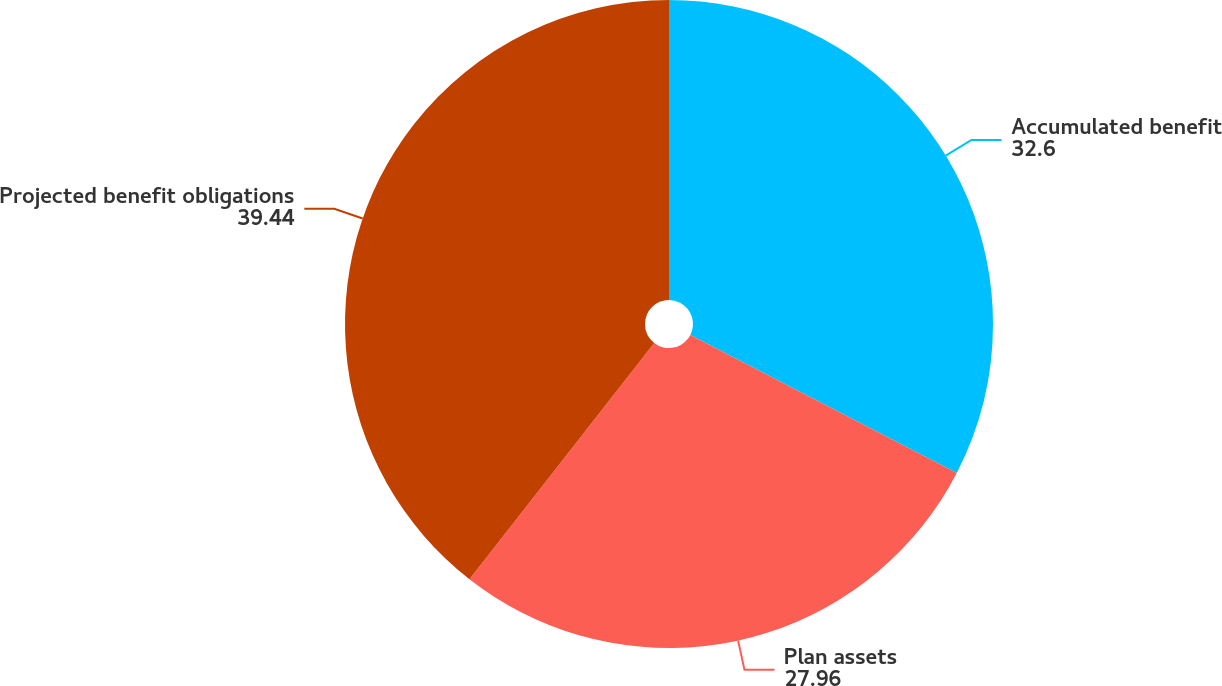Convert chart. <chart><loc_0><loc_0><loc_500><loc_500><pie_chart><fcel>Accumulated benefit<fcel>Plan assets<fcel>Projected benefit obligations<nl><fcel>32.6%<fcel>27.96%<fcel>39.44%<nl></chart> 